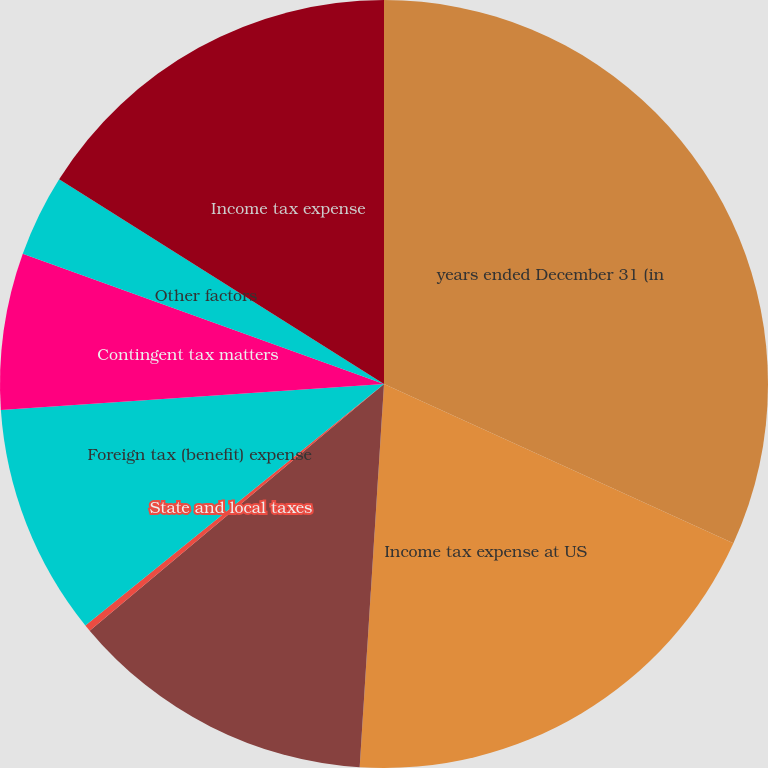Convert chart to OTSL. <chart><loc_0><loc_0><loc_500><loc_500><pie_chart><fcel>years ended December 31 (in<fcel>Income tax expense at US<fcel>Operations subject to tax<fcel>State and local taxes<fcel>Foreign tax (benefit) expense<fcel>Contingent tax matters<fcel>Other factors<fcel>Income tax expense<nl><fcel>31.81%<fcel>19.2%<fcel>12.89%<fcel>0.28%<fcel>9.74%<fcel>6.59%<fcel>3.44%<fcel>16.05%<nl></chart> 